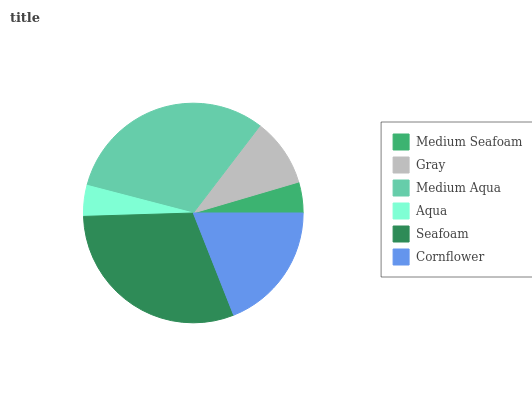Is Medium Seafoam the minimum?
Answer yes or no. Yes. Is Medium Aqua the maximum?
Answer yes or no. Yes. Is Gray the minimum?
Answer yes or no. No. Is Gray the maximum?
Answer yes or no. No. Is Gray greater than Medium Seafoam?
Answer yes or no. Yes. Is Medium Seafoam less than Gray?
Answer yes or no. Yes. Is Medium Seafoam greater than Gray?
Answer yes or no. No. Is Gray less than Medium Seafoam?
Answer yes or no. No. Is Cornflower the high median?
Answer yes or no. Yes. Is Gray the low median?
Answer yes or no. Yes. Is Medium Seafoam the high median?
Answer yes or no. No. Is Medium Aqua the low median?
Answer yes or no. No. 